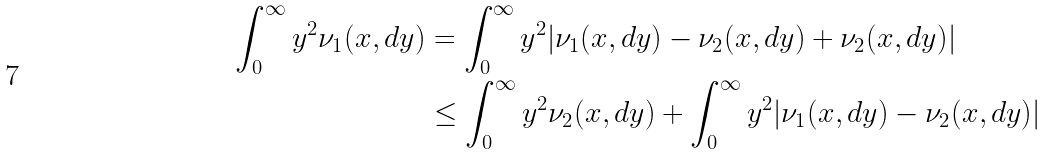<formula> <loc_0><loc_0><loc_500><loc_500>\int _ { 0 } ^ { \infty } y ^ { 2 } \nu _ { 1 } ( x , d y ) & = \int _ { 0 } ^ { \infty } y ^ { 2 } | \nu _ { 1 } ( x , d y ) - \nu _ { 2 } ( x , d y ) + \nu _ { 2 } ( x , d y ) | \\ & \leq \int _ { 0 } ^ { \infty } y ^ { 2 } \nu _ { 2 } ( x , d y ) + \int _ { 0 } ^ { \infty } y ^ { 2 } | \nu _ { 1 } ( x , d y ) - \nu _ { 2 } ( x , d y ) |</formula> 